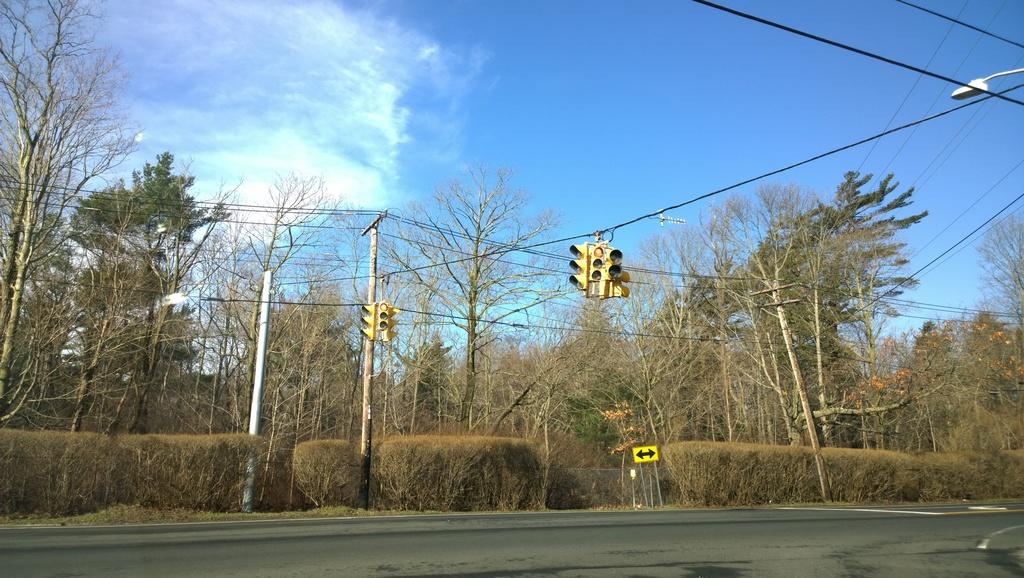What is located at the bottom of the image? There is a road at the bottom of the image. What can be seen in the background of the image? Trees, electric poles, wires, traffic signal poles, a direction board, and clouds are visible in the background of the image. What type of shirt is the belief wearing in the image? There is no belief or shirt present in the image. What sign can be seen on the direction board in the image? The provided facts do not mention any specific signs on the direction board, so we cannot answer this question definitively. 